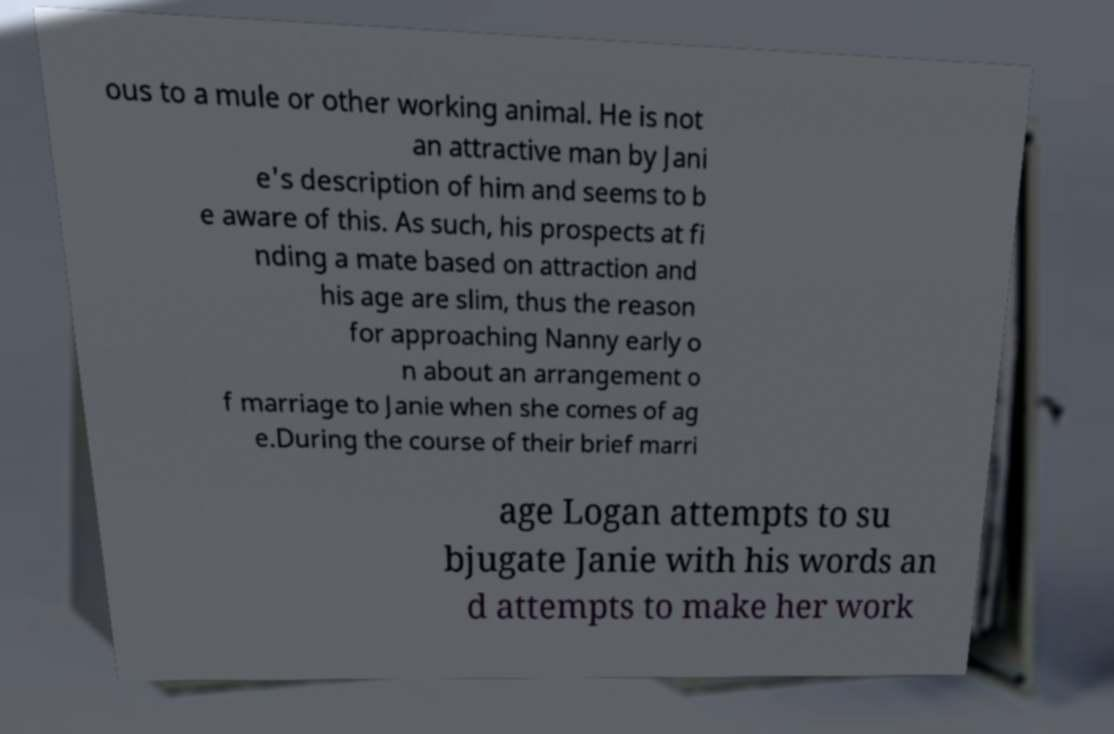Can you read and provide the text displayed in the image?This photo seems to have some interesting text. Can you extract and type it out for me? ous to a mule or other working animal. He is not an attractive man by Jani e's description of him and seems to b e aware of this. As such, his prospects at fi nding a mate based on attraction and his age are slim, thus the reason for approaching Nanny early o n about an arrangement o f marriage to Janie when she comes of ag e.During the course of their brief marri age Logan attempts to su bjugate Janie with his words an d attempts to make her work 